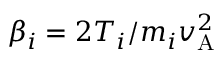<formula> <loc_0><loc_0><loc_500><loc_500>\beta _ { i } = 2 T _ { i } / m _ { i } v _ { A } ^ { 2 }</formula> 